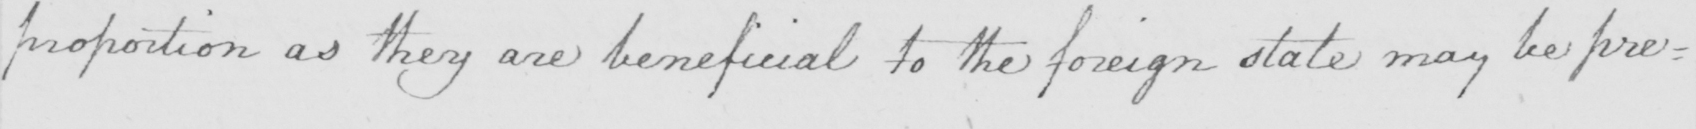Please provide the text content of this handwritten line. proportion as they are beneficial to the foreign state may be pre= 